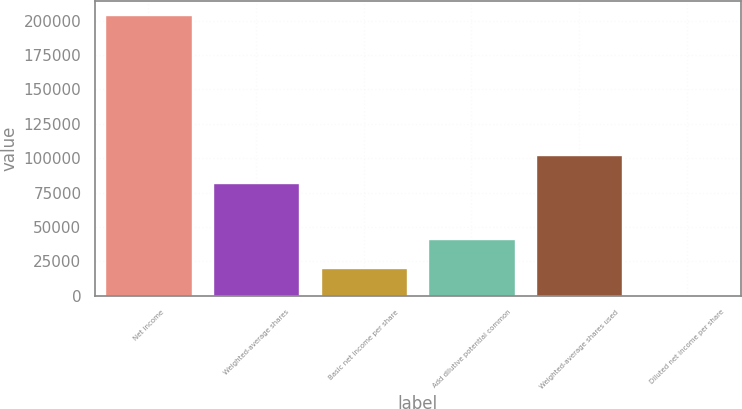Convert chart. <chart><loc_0><loc_0><loc_500><loc_500><bar_chart><fcel>Net income<fcel>Weighted-average shares<fcel>Basic net income per share<fcel>Add dilutive potential common<fcel>Weighted-average shares used<fcel>Diluted net income per share<nl><fcel>204315<fcel>81729.1<fcel>20436.1<fcel>40867.1<fcel>102160<fcel>5.12<nl></chart> 